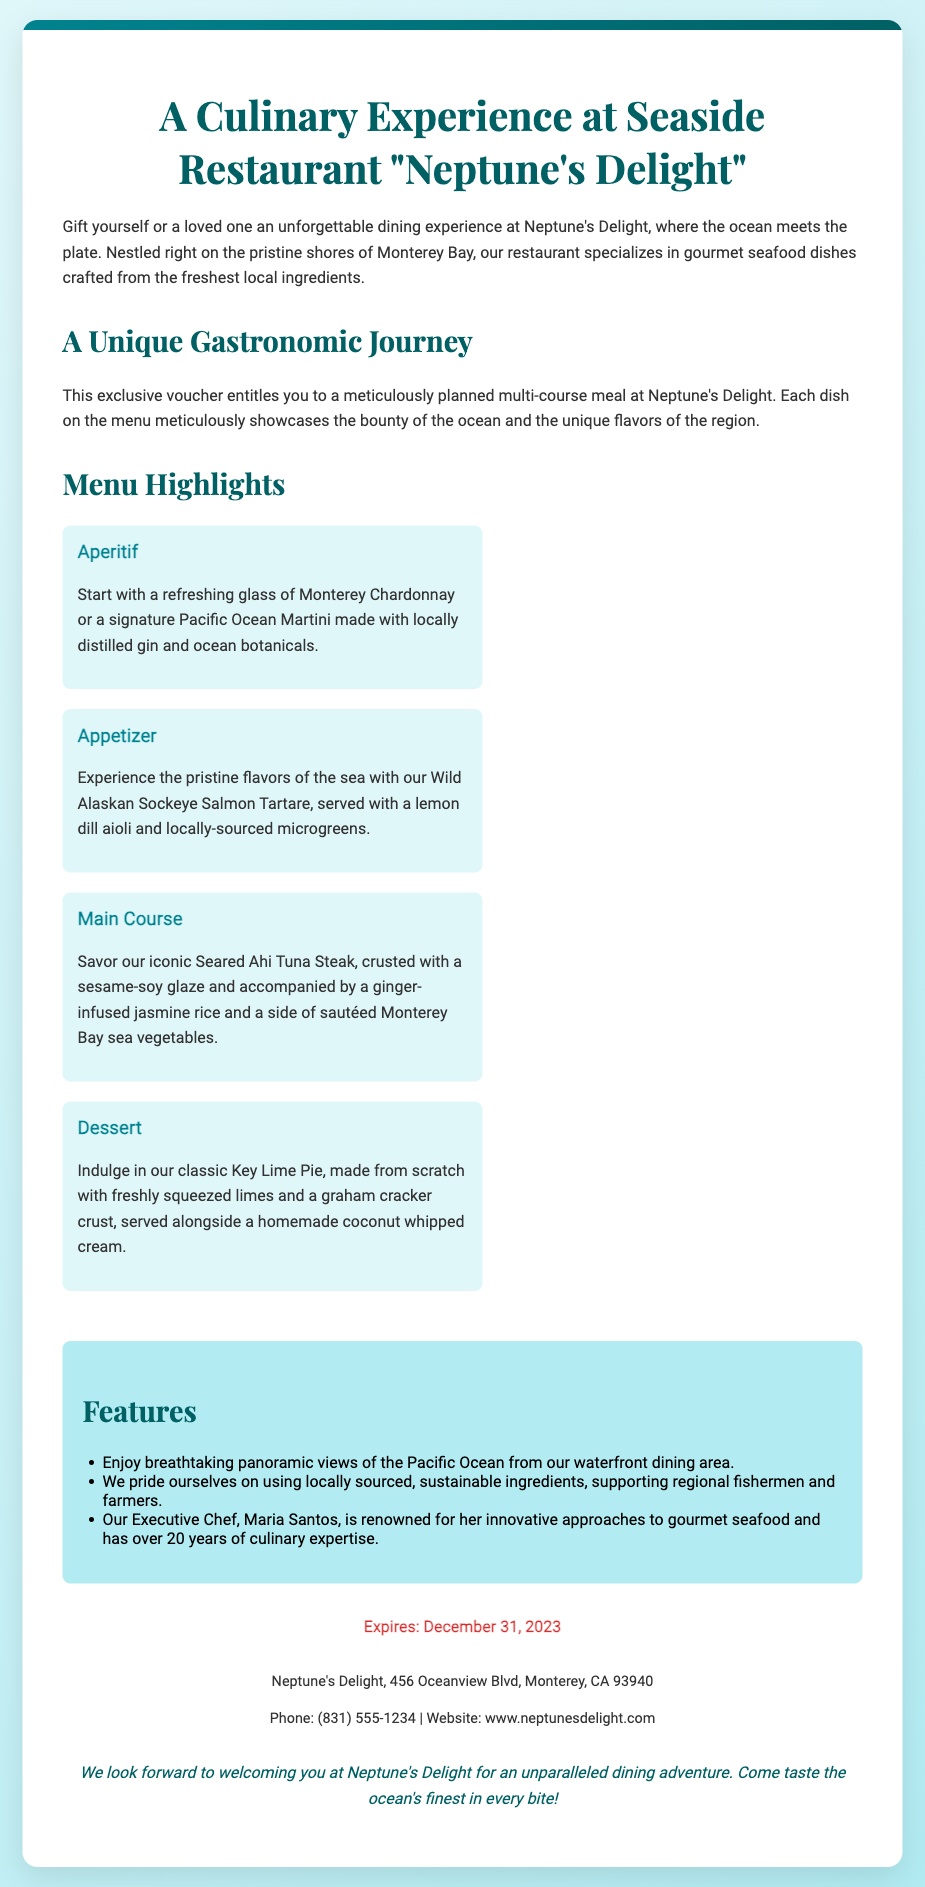What is the name of the restaurant? The restaurant mentioned in the document is called "Neptune's Delight."
Answer: Neptune's Delight What is the expiration date of the voucher? The document states that the voucher expires on December 31, 2023.
Answer: December 31, 2023 Who is the Executive Chef at Neptune's Delight? The document specifies that the Executive Chef's name is Maria Santos.
Answer: Maria Santos What beverage options are available as an aperitif? The document lists Monterey Chardonnay and a signature Pacific Ocean Martini as aperitif options.
Answer: Monterey Chardonnay, Pacific Ocean Martini What is featured as the main course? The main course specified in the document is the Seared Ahi Tuna Steak.
Answer: Seared Ahi Tuna Steak What culinary theme does the restaurant emphasize? The document states that Neptune's Delight emphasizes gourmet seafood crafted from locally sourced ingredients.
Answer: Gourmet seafood, locally sourced ingredients What type of views can diners enjoy at the restaurant? Diners can enjoy breathtaking panoramic views of the Pacific Ocean from the waterfront dining area.
Answer: Panoramic views of the Pacific Ocean How many courses are included in the dining experience? The document describes a multi-course meal, but does not specify an exact number.
Answer: Multi-course meal 